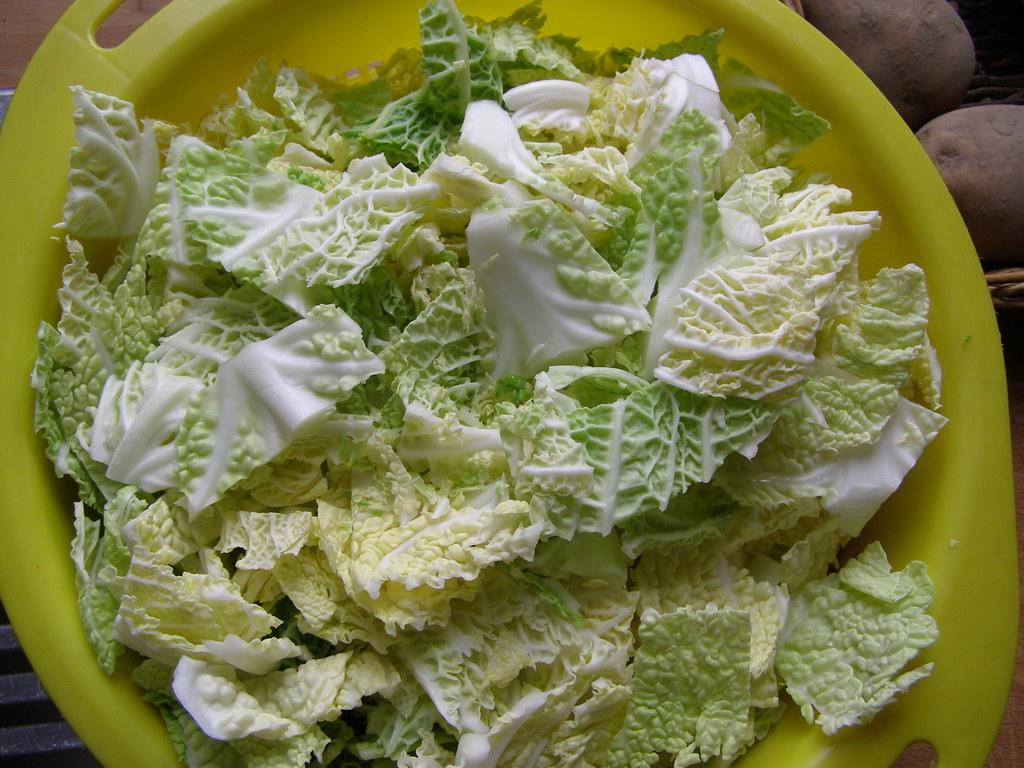What is located in the center of the image? There is a table in the center of the image. What is covering the table? There is a cloth on the table. What is placed on top of the cloth? There is a plate and a basket on the table. What type of food can be seen on the table? There are potatoes and cabbage visible on the table. Are there any other objects on the table besides the plate, basket, potatoes, and cabbage? Yes, there are other objects on the table. What type of mint is being discussed by the committee in the image? There is no committee or mint present in the image; it features a table with a cloth, plate, basket, potatoes, cabbage, and other objects. 